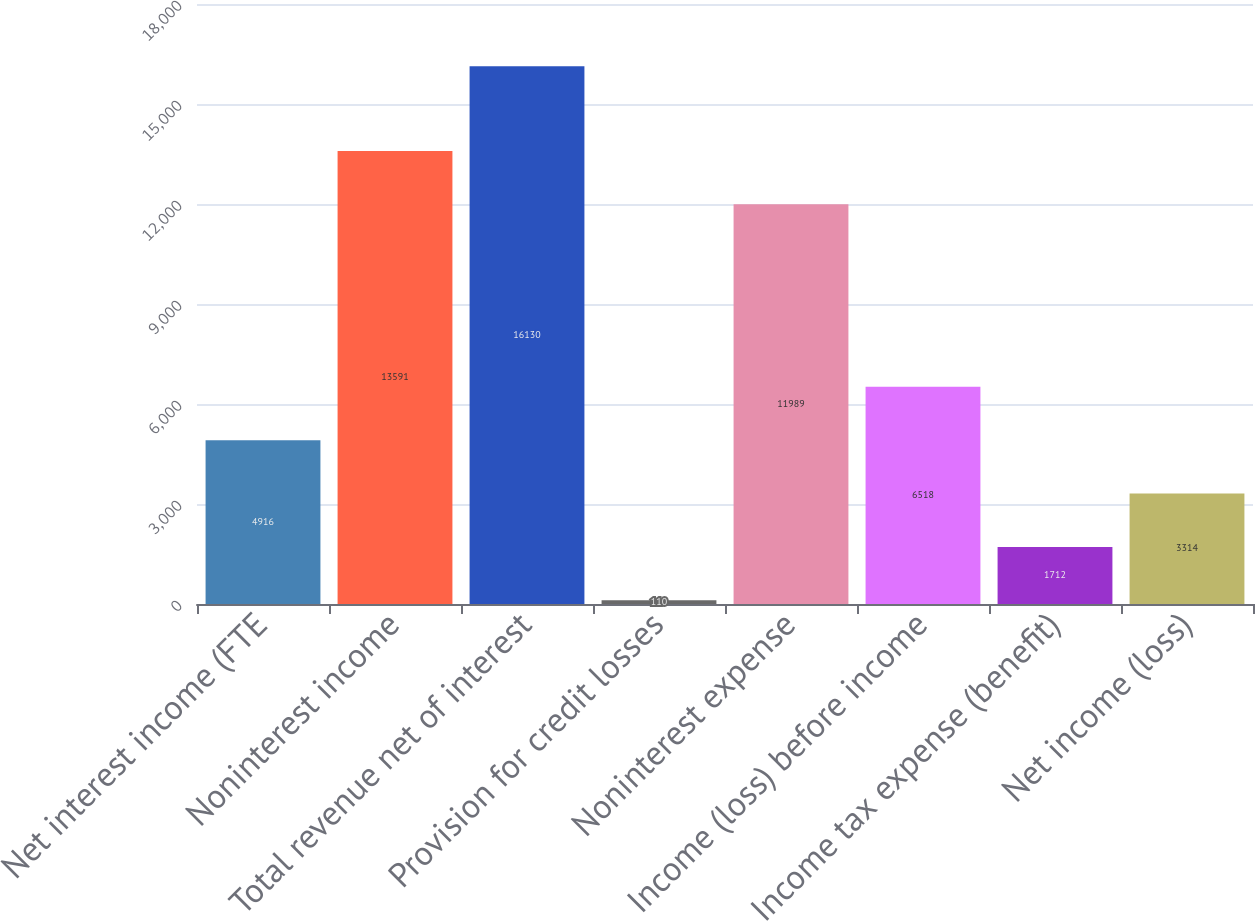Convert chart to OTSL. <chart><loc_0><loc_0><loc_500><loc_500><bar_chart><fcel>Net interest income (FTE<fcel>Noninterest income<fcel>Total revenue net of interest<fcel>Provision for credit losses<fcel>Noninterest expense<fcel>Income (loss) before income<fcel>Income tax expense (benefit)<fcel>Net income (loss)<nl><fcel>4916<fcel>13591<fcel>16130<fcel>110<fcel>11989<fcel>6518<fcel>1712<fcel>3314<nl></chart> 